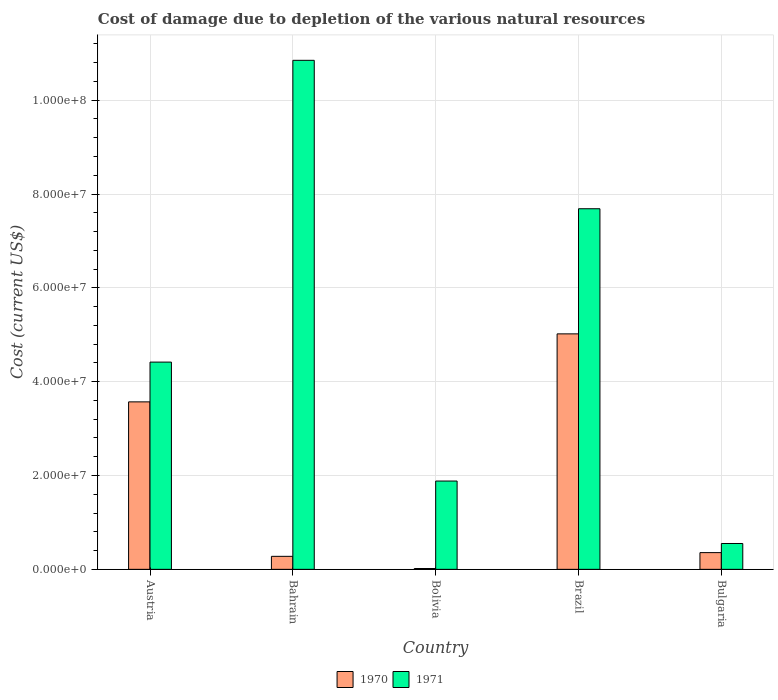How many groups of bars are there?
Keep it short and to the point. 5. Are the number of bars on each tick of the X-axis equal?
Provide a short and direct response. Yes. How many bars are there on the 1st tick from the left?
Offer a terse response. 2. What is the label of the 2nd group of bars from the left?
Keep it short and to the point. Bahrain. What is the cost of damage caused due to the depletion of various natural resources in 1971 in Austria?
Your answer should be very brief. 4.42e+07. Across all countries, what is the maximum cost of damage caused due to the depletion of various natural resources in 1971?
Offer a terse response. 1.09e+08. Across all countries, what is the minimum cost of damage caused due to the depletion of various natural resources in 1971?
Provide a succinct answer. 5.51e+06. In which country was the cost of damage caused due to the depletion of various natural resources in 1970 maximum?
Keep it short and to the point. Brazil. What is the total cost of damage caused due to the depletion of various natural resources in 1970 in the graph?
Ensure brevity in your answer.  9.24e+07. What is the difference between the cost of damage caused due to the depletion of various natural resources in 1970 in Bolivia and that in Brazil?
Offer a very short reply. -5.00e+07. What is the difference between the cost of damage caused due to the depletion of various natural resources in 1970 in Brazil and the cost of damage caused due to the depletion of various natural resources in 1971 in Bahrain?
Keep it short and to the point. -5.83e+07. What is the average cost of damage caused due to the depletion of various natural resources in 1970 per country?
Your answer should be compact. 1.85e+07. What is the difference between the cost of damage caused due to the depletion of various natural resources of/in 1970 and cost of damage caused due to the depletion of various natural resources of/in 1971 in Brazil?
Your response must be concise. -2.67e+07. In how many countries, is the cost of damage caused due to the depletion of various natural resources in 1971 greater than 64000000 US$?
Your answer should be very brief. 2. What is the ratio of the cost of damage caused due to the depletion of various natural resources in 1971 in Austria to that in Bulgaria?
Provide a short and direct response. 8.02. Is the cost of damage caused due to the depletion of various natural resources in 1970 in Bahrain less than that in Bolivia?
Give a very brief answer. No. What is the difference between the highest and the second highest cost of damage caused due to the depletion of various natural resources in 1970?
Provide a succinct answer. 1.45e+07. What is the difference between the highest and the lowest cost of damage caused due to the depletion of various natural resources in 1971?
Your response must be concise. 1.03e+08. In how many countries, is the cost of damage caused due to the depletion of various natural resources in 1971 greater than the average cost of damage caused due to the depletion of various natural resources in 1971 taken over all countries?
Make the answer very short. 2. What does the 1st bar from the left in Bulgaria represents?
Provide a succinct answer. 1970. How many bars are there?
Make the answer very short. 10. Are all the bars in the graph horizontal?
Offer a very short reply. No. How many countries are there in the graph?
Offer a terse response. 5. What is the difference between two consecutive major ticks on the Y-axis?
Keep it short and to the point. 2.00e+07. Does the graph contain any zero values?
Offer a very short reply. No. Does the graph contain grids?
Offer a terse response. Yes. How many legend labels are there?
Make the answer very short. 2. How are the legend labels stacked?
Give a very brief answer. Horizontal. What is the title of the graph?
Offer a terse response. Cost of damage due to depletion of the various natural resources. What is the label or title of the Y-axis?
Your response must be concise. Cost (current US$). What is the Cost (current US$) of 1970 in Austria?
Your response must be concise. 3.57e+07. What is the Cost (current US$) in 1971 in Austria?
Give a very brief answer. 4.42e+07. What is the Cost (current US$) of 1970 in Bahrain?
Keep it short and to the point. 2.77e+06. What is the Cost (current US$) of 1971 in Bahrain?
Give a very brief answer. 1.09e+08. What is the Cost (current US$) in 1970 in Bolivia?
Give a very brief answer. 1.74e+05. What is the Cost (current US$) of 1971 in Bolivia?
Your answer should be very brief. 1.88e+07. What is the Cost (current US$) of 1970 in Brazil?
Your response must be concise. 5.02e+07. What is the Cost (current US$) in 1971 in Brazil?
Offer a very short reply. 7.69e+07. What is the Cost (current US$) in 1970 in Bulgaria?
Offer a very short reply. 3.56e+06. What is the Cost (current US$) in 1971 in Bulgaria?
Give a very brief answer. 5.51e+06. Across all countries, what is the maximum Cost (current US$) of 1970?
Offer a very short reply. 5.02e+07. Across all countries, what is the maximum Cost (current US$) of 1971?
Your answer should be very brief. 1.09e+08. Across all countries, what is the minimum Cost (current US$) in 1970?
Make the answer very short. 1.74e+05. Across all countries, what is the minimum Cost (current US$) of 1971?
Provide a succinct answer. 5.51e+06. What is the total Cost (current US$) in 1970 in the graph?
Give a very brief answer. 9.24e+07. What is the total Cost (current US$) in 1971 in the graph?
Offer a very short reply. 2.54e+08. What is the difference between the Cost (current US$) in 1970 in Austria and that in Bahrain?
Offer a terse response. 3.29e+07. What is the difference between the Cost (current US$) in 1971 in Austria and that in Bahrain?
Offer a very short reply. -6.43e+07. What is the difference between the Cost (current US$) in 1970 in Austria and that in Bolivia?
Your response must be concise. 3.55e+07. What is the difference between the Cost (current US$) in 1971 in Austria and that in Bolivia?
Keep it short and to the point. 2.54e+07. What is the difference between the Cost (current US$) in 1970 in Austria and that in Brazil?
Your answer should be very brief. -1.45e+07. What is the difference between the Cost (current US$) of 1971 in Austria and that in Brazil?
Offer a terse response. -3.27e+07. What is the difference between the Cost (current US$) in 1970 in Austria and that in Bulgaria?
Offer a terse response. 3.21e+07. What is the difference between the Cost (current US$) in 1971 in Austria and that in Bulgaria?
Offer a very short reply. 3.87e+07. What is the difference between the Cost (current US$) of 1970 in Bahrain and that in Bolivia?
Your response must be concise. 2.60e+06. What is the difference between the Cost (current US$) in 1971 in Bahrain and that in Bolivia?
Offer a very short reply. 8.97e+07. What is the difference between the Cost (current US$) of 1970 in Bahrain and that in Brazil?
Provide a short and direct response. -4.74e+07. What is the difference between the Cost (current US$) in 1971 in Bahrain and that in Brazil?
Your response must be concise. 3.16e+07. What is the difference between the Cost (current US$) in 1970 in Bahrain and that in Bulgaria?
Your answer should be compact. -7.93e+05. What is the difference between the Cost (current US$) of 1971 in Bahrain and that in Bulgaria?
Ensure brevity in your answer.  1.03e+08. What is the difference between the Cost (current US$) of 1970 in Bolivia and that in Brazil?
Your answer should be very brief. -5.00e+07. What is the difference between the Cost (current US$) of 1971 in Bolivia and that in Brazil?
Give a very brief answer. -5.80e+07. What is the difference between the Cost (current US$) of 1970 in Bolivia and that in Bulgaria?
Your answer should be very brief. -3.39e+06. What is the difference between the Cost (current US$) in 1971 in Bolivia and that in Bulgaria?
Offer a very short reply. 1.33e+07. What is the difference between the Cost (current US$) in 1970 in Brazil and that in Bulgaria?
Your response must be concise. 4.66e+07. What is the difference between the Cost (current US$) in 1971 in Brazil and that in Bulgaria?
Give a very brief answer. 7.14e+07. What is the difference between the Cost (current US$) in 1970 in Austria and the Cost (current US$) in 1971 in Bahrain?
Your answer should be compact. -7.28e+07. What is the difference between the Cost (current US$) in 1970 in Austria and the Cost (current US$) in 1971 in Bolivia?
Your answer should be compact. 1.69e+07. What is the difference between the Cost (current US$) in 1970 in Austria and the Cost (current US$) in 1971 in Brazil?
Offer a very short reply. -4.12e+07. What is the difference between the Cost (current US$) of 1970 in Austria and the Cost (current US$) of 1971 in Bulgaria?
Offer a very short reply. 3.02e+07. What is the difference between the Cost (current US$) of 1970 in Bahrain and the Cost (current US$) of 1971 in Bolivia?
Give a very brief answer. -1.61e+07. What is the difference between the Cost (current US$) of 1970 in Bahrain and the Cost (current US$) of 1971 in Brazil?
Offer a terse response. -7.41e+07. What is the difference between the Cost (current US$) in 1970 in Bahrain and the Cost (current US$) in 1971 in Bulgaria?
Make the answer very short. -2.74e+06. What is the difference between the Cost (current US$) in 1970 in Bolivia and the Cost (current US$) in 1971 in Brazil?
Your answer should be very brief. -7.67e+07. What is the difference between the Cost (current US$) of 1970 in Bolivia and the Cost (current US$) of 1971 in Bulgaria?
Offer a very short reply. -5.33e+06. What is the difference between the Cost (current US$) in 1970 in Brazil and the Cost (current US$) in 1971 in Bulgaria?
Your answer should be very brief. 4.47e+07. What is the average Cost (current US$) in 1970 per country?
Offer a very short reply. 1.85e+07. What is the average Cost (current US$) of 1971 per country?
Your response must be concise. 5.08e+07. What is the difference between the Cost (current US$) of 1970 and Cost (current US$) of 1971 in Austria?
Give a very brief answer. -8.48e+06. What is the difference between the Cost (current US$) in 1970 and Cost (current US$) in 1971 in Bahrain?
Offer a very short reply. -1.06e+08. What is the difference between the Cost (current US$) of 1970 and Cost (current US$) of 1971 in Bolivia?
Ensure brevity in your answer.  -1.86e+07. What is the difference between the Cost (current US$) of 1970 and Cost (current US$) of 1971 in Brazil?
Provide a succinct answer. -2.67e+07. What is the difference between the Cost (current US$) of 1970 and Cost (current US$) of 1971 in Bulgaria?
Offer a terse response. -1.95e+06. What is the ratio of the Cost (current US$) in 1970 in Austria to that in Bahrain?
Your answer should be very brief. 12.89. What is the ratio of the Cost (current US$) in 1971 in Austria to that in Bahrain?
Give a very brief answer. 0.41. What is the ratio of the Cost (current US$) in 1970 in Austria to that in Bolivia?
Your answer should be very brief. 204.62. What is the ratio of the Cost (current US$) in 1971 in Austria to that in Bolivia?
Your answer should be very brief. 2.35. What is the ratio of the Cost (current US$) of 1970 in Austria to that in Brazil?
Your response must be concise. 0.71. What is the ratio of the Cost (current US$) in 1971 in Austria to that in Brazil?
Your answer should be compact. 0.57. What is the ratio of the Cost (current US$) of 1970 in Austria to that in Bulgaria?
Offer a very short reply. 10.02. What is the ratio of the Cost (current US$) in 1971 in Austria to that in Bulgaria?
Ensure brevity in your answer.  8.02. What is the ratio of the Cost (current US$) in 1970 in Bahrain to that in Bolivia?
Keep it short and to the point. 15.88. What is the ratio of the Cost (current US$) in 1971 in Bahrain to that in Bolivia?
Offer a very short reply. 5.77. What is the ratio of the Cost (current US$) in 1970 in Bahrain to that in Brazil?
Your answer should be compact. 0.06. What is the ratio of the Cost (current US$) in 1971 in Bahrain to that in Brazil?
Your answer should be very brief. 1.41. What is the ratio of the Cost (current US$) of 1970 in Bahrain to that in Bulgaria?
Keep it short and to the point. 0.78. What is the ratio of the Cost (current US$) of 1971 in Bahrain to that in Bulgaria?
Ensure brevity in your answer.  19.7. What is the ratio of the Cost (current US$) in 1970 in Bolivia to that in Brazil?
Make the answer very short. 0. What is the ratio of the Cost (current US$) in 1971 in Bolivia to that in Brazil?
Keep it short and to the point. 0.24. What is the ratio of the Cost (current US$) in 1970 in Bolivia to that in Bulgaria?
Offer a terse response. 0.05. What is the ratio of the Cost (current US$) in 1971 in Bolivia to that in Bulgaria?
Ensure brevity in your answer.  3.42. What is the ratio of the Cost (current US$) of 1970 in Brazil to that in Bulgaria?
Provide a succinct answer. 14.09. What is the ratio of the Cost (current US$) of 1971 in Brazil to that in Bulgaria?
Offer a terse response. 13.95. What is the difference between the highest and the second highest Cost (current US$) in 1970?
Make the answer very short. 1.45e+07. What is the difference between the highest and the second highest Cost (current US$) in 1971?
Provide a succinct answer. 3.16e+07. What is the difference between the highest and the lowest Cost (current US$) of 1970?
Provide a short and direct response. 5.00e+07. What is the difference between the highest and the lowest Cost (current US$) in 1971?
Provide a succinct answer. 1.03e+08. 